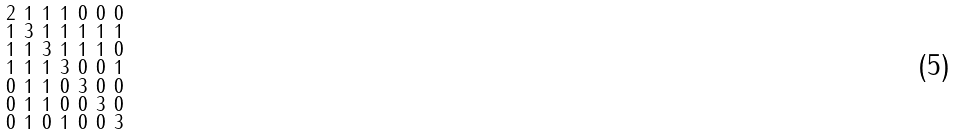<formula> <loc_0><loc_0><loc_500><loc_500>\begin{smallmatrix} 2 & 1 & 1 & 1 & 0 & 0 & 0 \\ 1 & 3 & 1 & 1 & 1 & 1 & 1 \\ 1 & 1 & 3 & 1 & 1 & 1 & 0 \\ 1 & 1 & 1 & 3 & 0 & 0 & 1 \\ 0 & 1 & 1 & 0 & 3 & 0 & 0 \\ 0 & 1 & 1 & 0 & 0 & 3 & 0 \\ 0 & 1 & 0 & 1 & 0 & 0 & 3 \end{smallmatrix}</formula> 